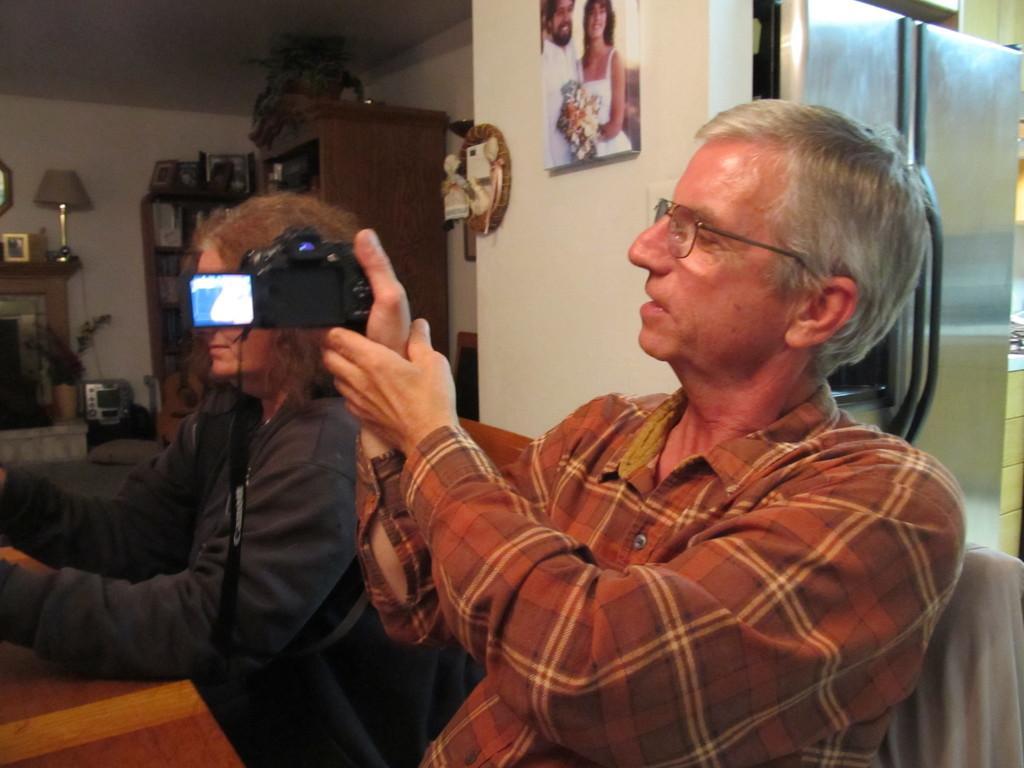Describe this image in one or two sentences. In the center of the image there are two people sitting. The man who is wearing glasses is holding a camera in his hand and there is a lady sitting next to him. In the background there is a cupboard, table, shelves, refrigerator and a photo frame which is placed on the wall. 